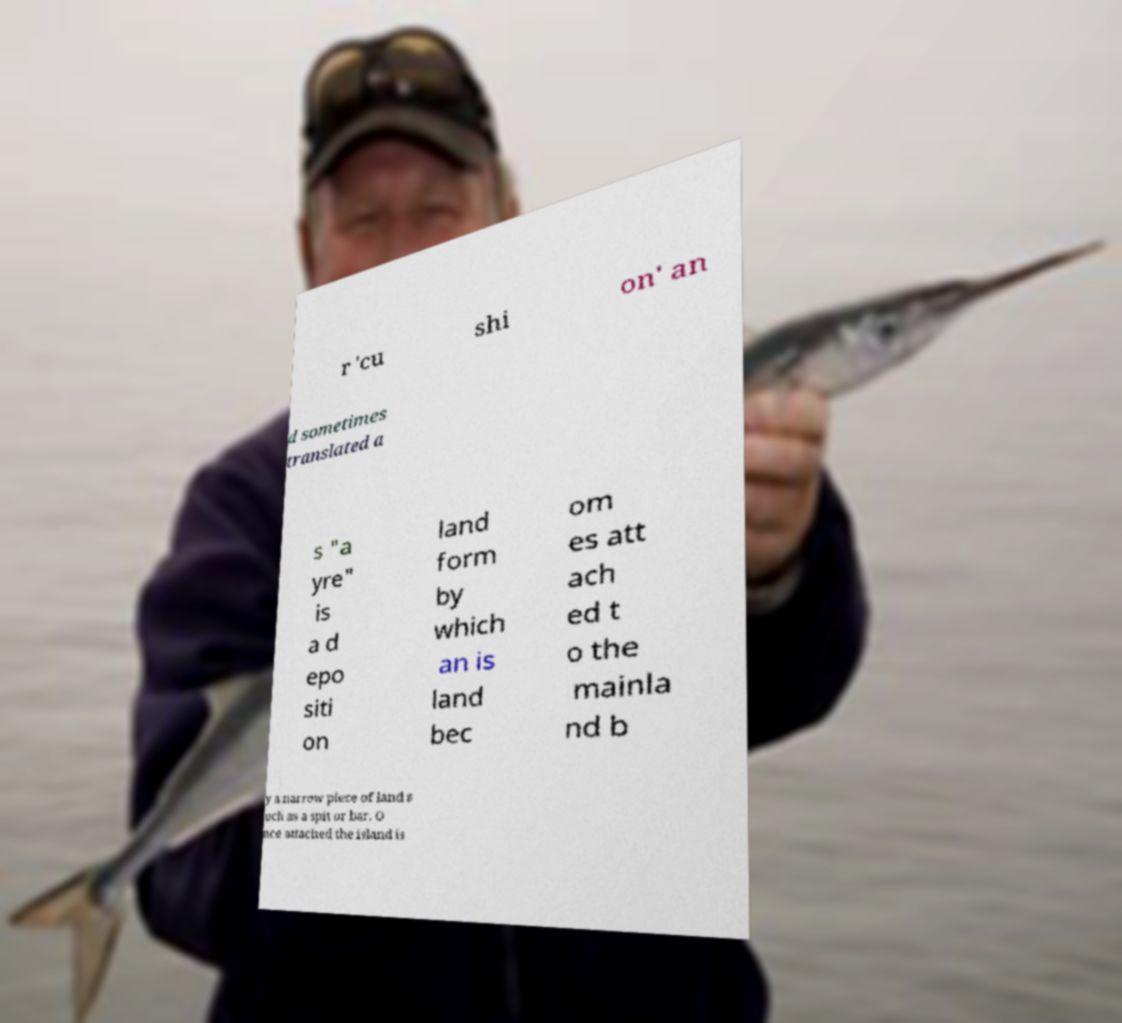I need the written content from this picture converted into text. Can you do that? r 'cu shi on' an d sometimes translated a s "a yre" is a d epo siti on land form by which an is land bec om es att ach ed t o the mainla nd b y a narrow piece of land s uch as a spit or bar. O nce attached the island is 